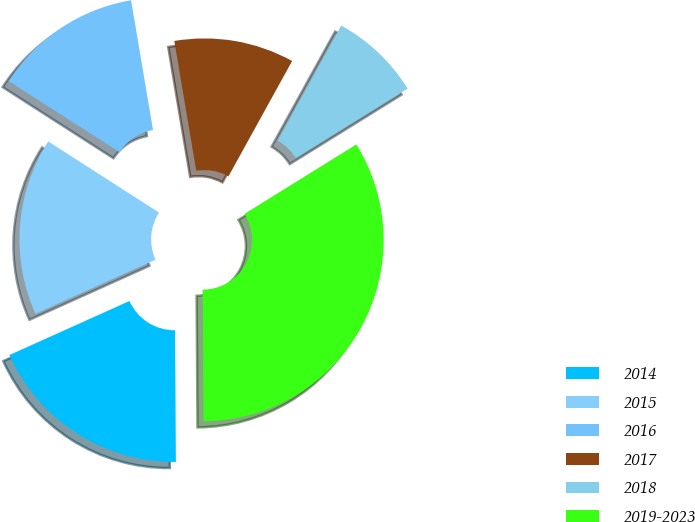Convert chart to OTSL. <chart><loc_0><loc_0><loc_500><loc_500><pie_chart><fcel>2014<fcel>2015<fcel>2016<fcel>2017<fcel>2018<fcel>2019-2023<nl><fcel>18.37%<fcel>15.81%<fcel>13.25%<fcel>10.69%<fcel>8.13%<fcel>33.73%<nl></chart> 